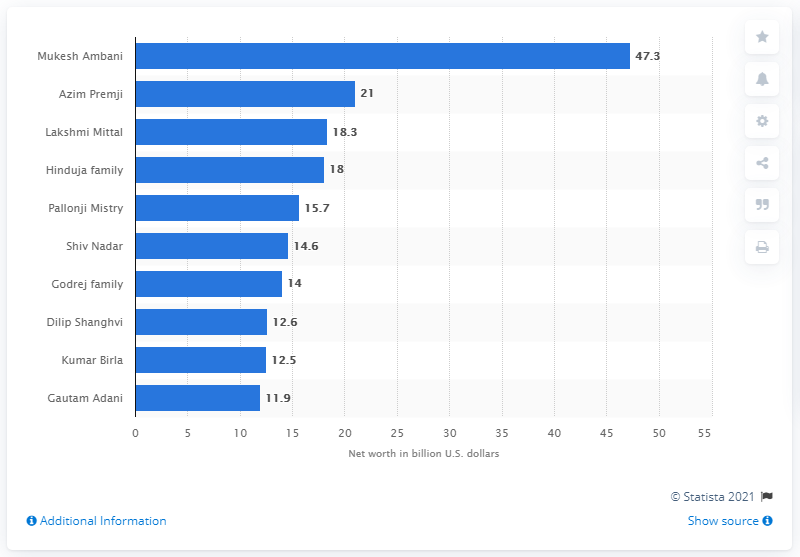Indicate a few pertinent items in this graphic. The net worth of Mukesh Ambani is 47.3 billion US dollars. Mukesh Ambani is considered the richest man in India. Mukesh Ambani is considered to be the richest person in India. 